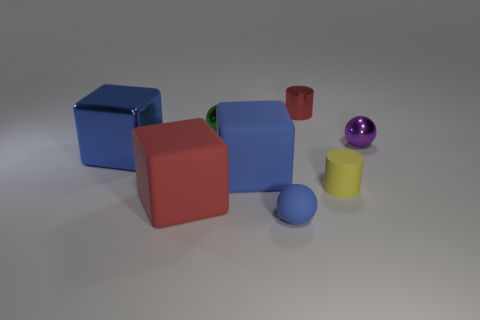Subtract all red cylinders. How many blue cubes are left? 2 Add 2 small red cylinders. How many objects exist? 10 Subtract 1 blocks. How many blocks are left? 2 Subtract all big blue cubes. How many cubes are left? 1 Subtract all cylinders. How many objects are left? 6 Subtract 0 yellow blocks. How many objects are left? 8 Subtract all yellow cylinders. Subtract all gray matte things. How many objects are left? 7 Add 4 blue metallic objects. How many blue metallic objects are left? 5 Add 7 yellow objects. How many yellow objects exist? 8 